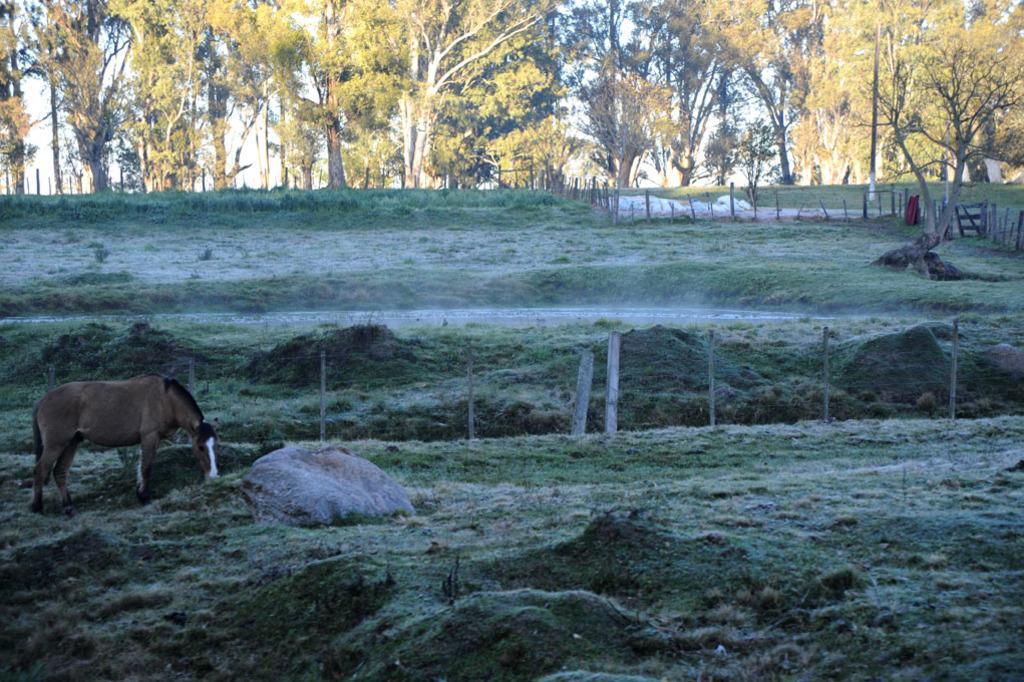What is the main setting of the image? There is an open grass ground in the image. What animal can be seen on the grass ground? A horse is standing on the grass ground. What can be seen in the background of the image? There are trees and poles in the background of the image. What type of cast can be seen on the horse's leg in the image? There is no cast visible on the horse's leg in the image. What kind of lumber is being used to construct the poles in the background? There is no lumber visible in the image, as the poles are not being constructed. 